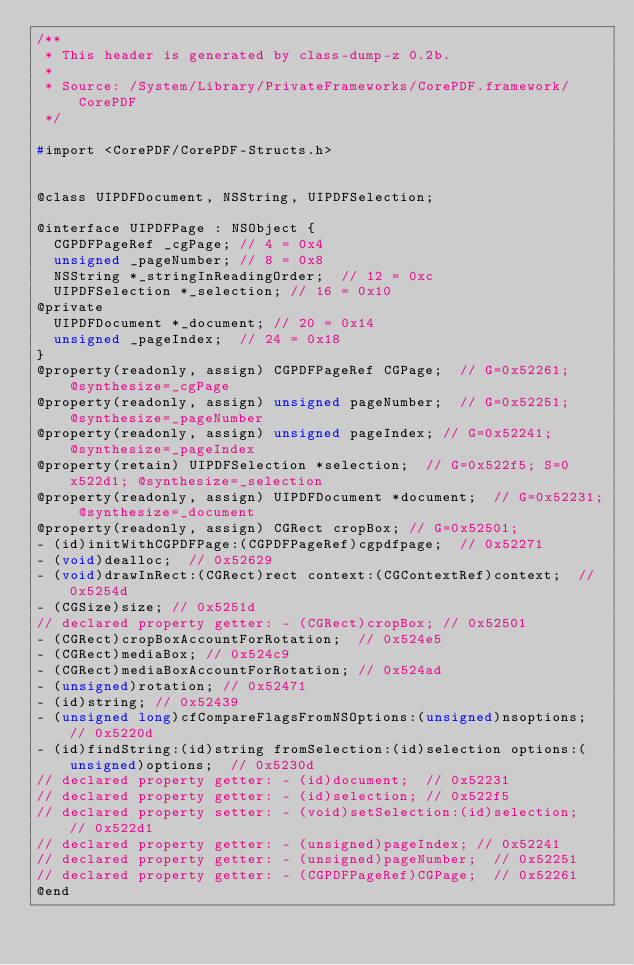Convert code to text. <code><loc_0><loc_0><loc_500><loc_500><_C_>/**
 * This header is generated by class-dump-z 0.2b.
 *
 * Source: /System/Library/PrivateFrameworks/CorePDF.framework/CorePDF
 */

#import <CorePDF/CorePDF-Structs.h>


@class UIPDFDocument, NSString, UIPDFSelection;

@interface UIPDFPage : NSObject {
	CGPDFPageRef _cgPage;	// 4 = 0x4
	unsigned _pageNumber;	// 8 = 0x8
	NSString *_stringInReadingOrder;	// 12 = 0xc
	UIPDFSelection *_selection;	// 16 = 0x10
@private
	UIPDFDocument *_document;	// 20 = 0x14
	unsigned _pageIndex;	// 24 = 0x18
}
@property(readonly, assign) CGPDFPageRef CGPage;	// G=0x52261; @synthesize=_cgPage
@property(readonly, assign) unsigned pageNumber;	// G=0x52251; @synthesize=_pageNumber
@property(readonly, assign) unsigned pageIndex;	// G=0x52241; @synthesize=_pageIndex
@property(retain) UIPDFSelection *selection;	// G=0x522f5; S=0x522d1; @synthesize=_selection
@property(readonly, assign) UIPDFDocument *document;	// G=0x52231; @synthesize=_document
@property(readonly, assign) CGRect cropBox;	// G=0x52501; 
- (id)initWithCGPDFPage:(CGPDFPageRef)cgpdfpage;	// 0x52271
- (void)dealloc;	// 0x52629
- (void)drawInRect:(CGRect)rect context:(CGContextRef)context;	// 0x5254d
- (CGSize)size;	// 0x5251d
// declared property getter: - (CGRect)cropBox;	// 0x52501
- (CGRect)cropBoxAccountForRotation;	// 0x524e5
- (CGRect)mediaBox;	// 0x524c9
- (CGRect)mediaBoxAccountForRotation;	// 0x524ad
- (unsigned)rotation;	// 0x52471
- (id)string;	// 0x52439
- (unsigned long)cfCompareFlagsFromNSOptions:(unsigned)nsoptions;	// 0x5220d
- (id)findString:(id)string fromSelection:(id)selection options:(unsigned)options;	// 0x5230d
// declared property getter: - (id)document;	// 0x52231
// declared property getter: - (id)selection;	// 0x522f5
// declared property setter: - (void)setSelection:(id)selection;	// 0x522d1
// declared property getter: - (unsigned)pageIndex;	// 0x52241
// declared property getter: - (unsigned)pageNumber;	// 0x52251
// declared property getter: - (CGPDFPageRef)CGPage;	// 0x52261
@end
</code> 